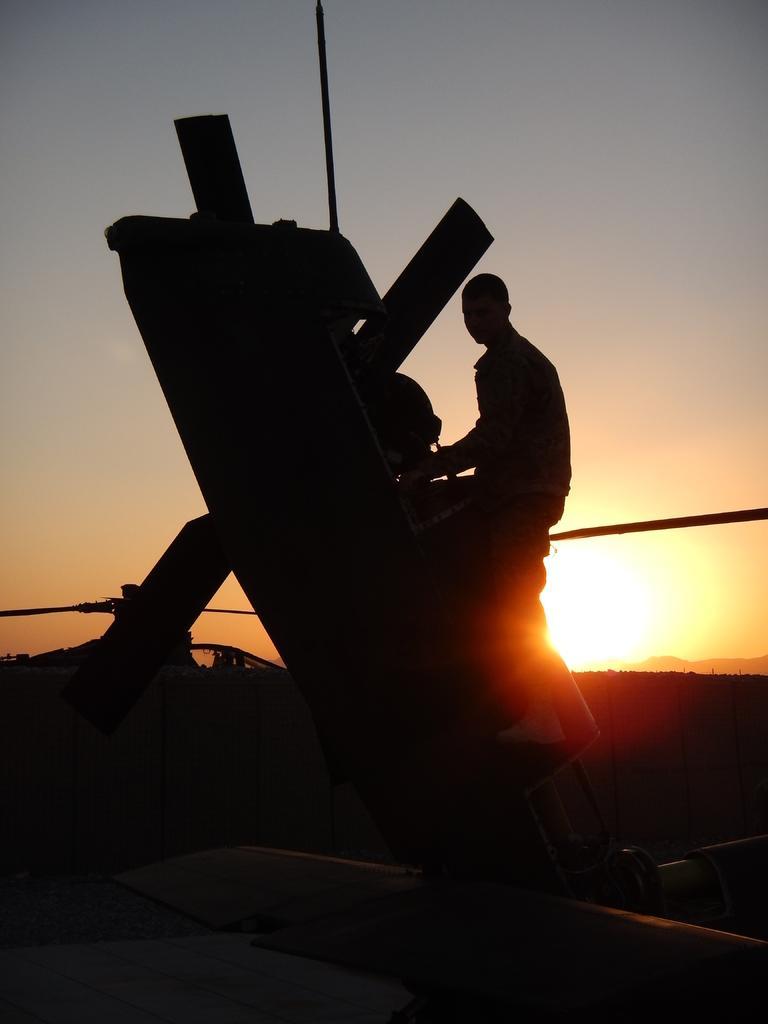Could you give a brief overview of what you see in this image? In this image I can see a object and one person is holding it. Sky is in grey,white and orange color. 